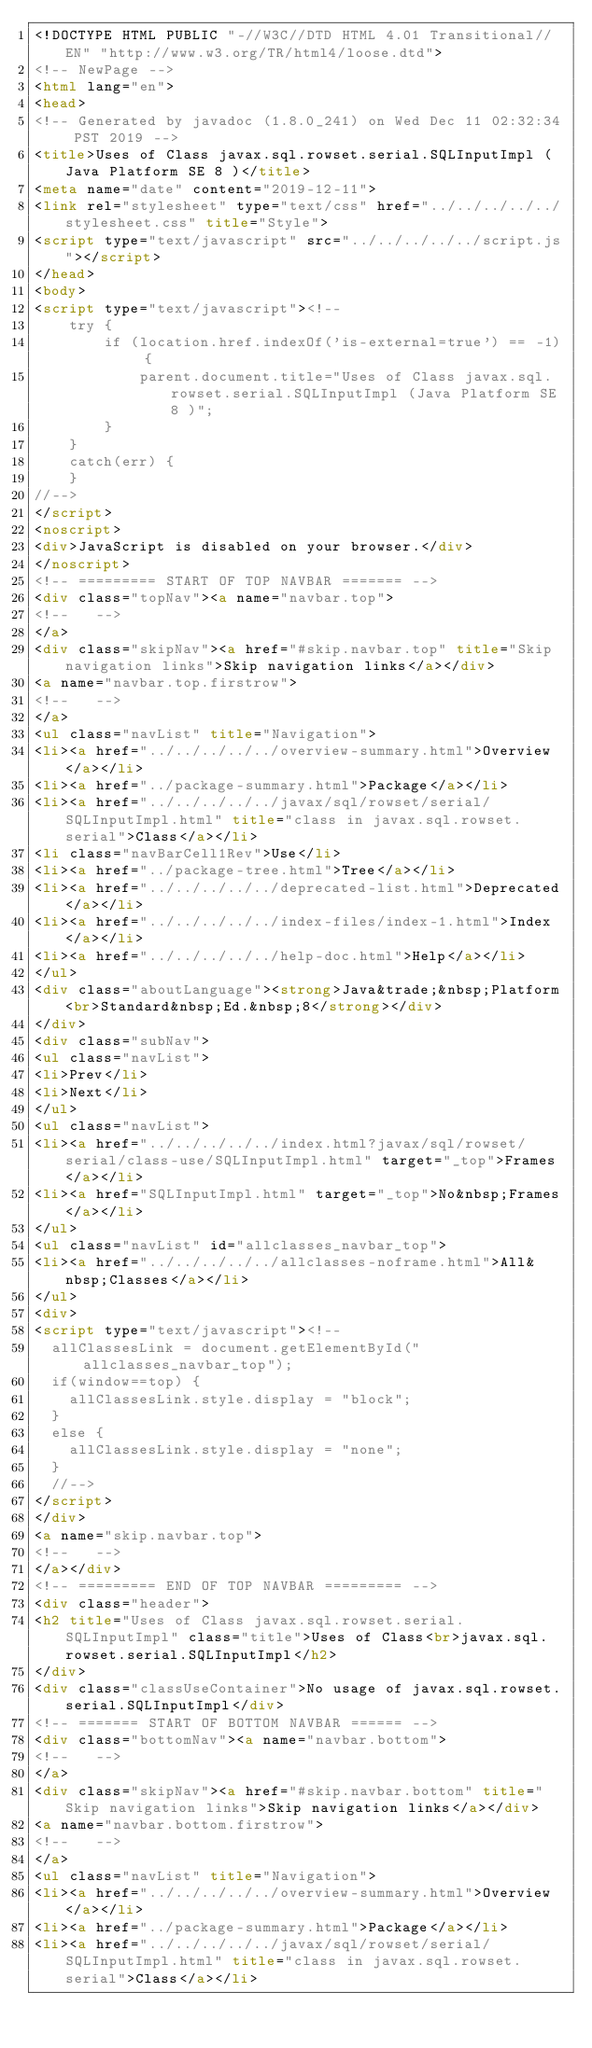Convert code to text. <code><loc_0><loc_0><loc_500><loc_500><_HTML_><!DOCTYPE HTML PUBLIC "-//W3C//DTD HTML 4.01 Transitional//EN" "http://www.w3.org/TR/html4/loose.dtd">
<!-- NewPage -->
<html lang="en">
<head>
<!-- Generated by javadoc (1.8.0_241) on Wed Dec 11 02:32:34 PST 2019 -->
<title>Uses of Class javax.sql.rowset.serial.SQLInputImpl (Java Platform SE 8 )</title>
<meta name="date" content="2019-12-11">
<link rel="stylesheet" type="text/css" href="../../../../../stylesheet.css" title="Style">
<script type="text/javascript" src="../../../../../script.js"></script>
</head>
<body>
<script type="text/javascript"><!--
    try {
        if (location.href.indexOf('is-external=true') == -1) {
            parent.document.title="Uses of Class javax.sql.rowset.serial.SQLInputImpl (Java Platform SE 8 )";
        }
    }
    catch(err) {
    }
//-->
</script>
<noscript>
<div>JavaScript is disabled on your browser.</div>
</noscript>
<!-- ========= START OF TOP NAVBAR ======= -->
<div class="topNav"><a name="navbar.top">
<!--   -->
</a>
<div class="skipNav"><a href="#skip.navbar.top" title="Skip navigation links">Skip navigation links</a></div>
<a name="navbar.top.firstrow">
<!--   -->
</a>
<ul class="navList" title="Navigation">
<li><a href="../../../../../overview-summary.html">Overview</a></li>
<li><a href="../package-summary.html">Package</a></li>
<li><a href="../../../../../javax/sql/rowset/serial/SQLInputImpl.html" title="class in javax.sql.rowset.serial">Class</a></li>
<li class="navBarCell1Rev">Use</li>
<li><a href="../package-tree.html">Tree</a></li>
<li><a href="../../../../../deprecated-list.html">Deprecated</a></li>
<li><a href="../../../../../index-files/index-1.html">Index</a></li>
<li><a href="../../../../../help-doc.html">Help</a></li>
</ul>
<div class="aboutLanguage"><strong>Java&trade;&nbsp;Platform<br>Standard&nbsp;Ed.&nbsp;8</strong></div>
</div>
<div class="subNav">
<ul class="navList">
<li>Prev</li>
<li>Next</li>
</ul>
<ul class="navList">
<li><a href="../../../../../index.html?javax/sql/rowset/serial/class-use/SQLInputImpl.html" target="_top">Frames</a></li>
<li><a href="SQLInputImpl.html" target="_top">No&nbsp;Frames</a></li>
</ul>
<ul class="navList" id="allclasses_navbar_top">
<li><a href="../../../../../allclasses-noframe.html">All&nbsp;Classes</a></li>
</ul>
<div>
<script type="text/javascript"><!--
  allClassesLink = document.getElementById("allclasses_navbar_top");
  if(window==top) {
    allClassesLink.style.display = "block";
  }
  else {
    allClassesLink.style.display = "none";
  }
  //-->
</script>
</div>
<a name="skip.navbar.top">
<!--   -->
</a></div>
<!-- ========= END OF TOP NAVBAR ========= -->
<div class="header">
<h2 title="Uses of Class javax.sql.rowset.serial.SQLInputImpl" class="title">Uses of Class<br>javax.sql.rowset.serial.SQLInputImpl</h2>
</div>
<div class="classUseContainer">No usage of javax.sql.rowset.serial.SQLInputImpl</div>
<!-- ======= START OF BOTTOM NAVBAR ====== -->
<div class="bottomNav"><a name="navbar.bottom">
<!--   -->
</a>
<div class="skipNav"><a href="#skip.navbar.bottom" title="Skip navigation links">Skip navigation links</a></div>
<a name="navbar.bottom.firstrow">
<!--   -->
</a>
<ul class="navList" title="Navigation">
<li><a href="../../../../../overview-summary.html">Overview</a></li>
<li><a href="../package-summary.html">Package</a></li>
<li><a href="../../../../../javax/sql/rowset/serial/SQLInputImpl.html" title="class in javax.sql.rowset.serial">Class</a></li></code> 